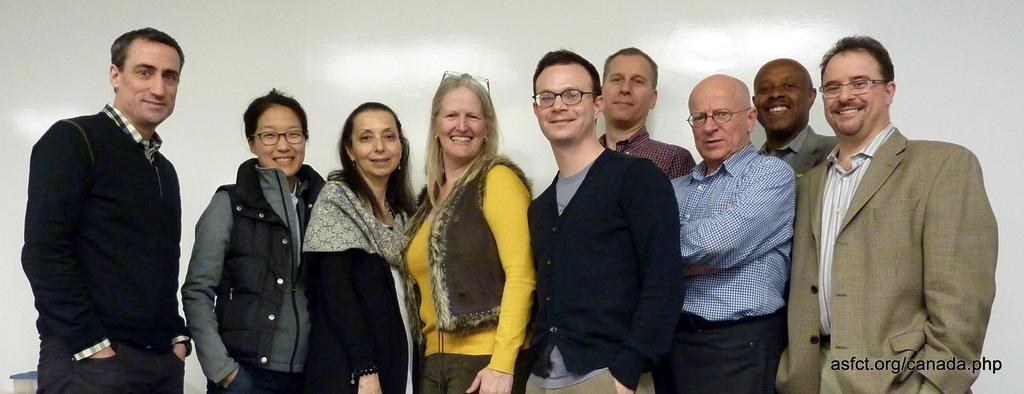How many people are in the image? There is a group of people in the image. What are the people doing in the image? The people are standing and smiling. What can be seen in the background of the image? There is a wall visible in the background of the image. What is present in the bottom right corner of the image? There is text in the bottom right corner of the image. How many bikes are parked next to the people in the image? There are no bikes present in the image. What type of business is being conducted in the image? The image does not depict any business activity; it shows a group of people standing and smiling. 